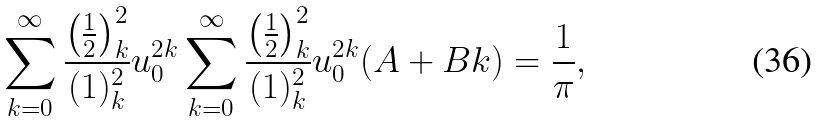Convert formula to latex. <formula><loc_0><loc_0><loc_500><loc_500>\sum _ { k = 0 } ^ { \infty } \frac { \left ( \frac { 1 } { 2 } \right ) _ { k } ^ { 2 } } { ( 1 ) _ { k } ^ { 2 } } u _ { 0 } ^ { 2 k } \sum _ { k = 0 } ^ { \infty } \frac { \left ( \frac { 1 } { 2 } \right ) _ { k } ^ { 2 } } { ( 1 ) _ { k } ^ { 2 } } u _ { 0 } ^ { 2 k } ( A + B k ) = \frac { 1 } { \pi } ,</formula> 